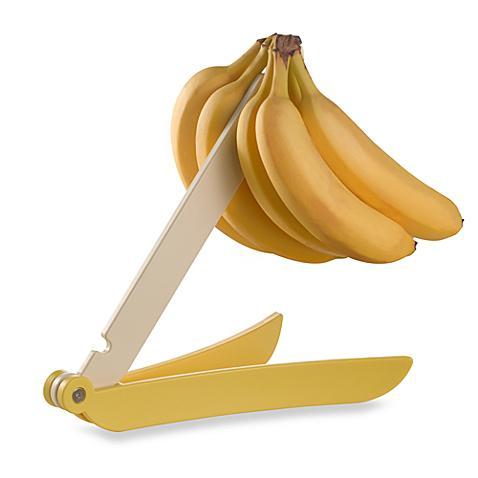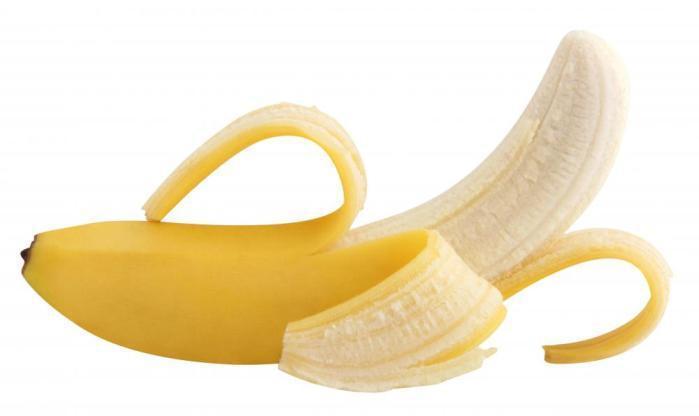The first image is the image on the left, the second image is the image on the right. Evaluate the accuracy of this statement regarding the images: "In one of the images, at least part of a banana has been cut into slices.". Is it true? Answer yes or no. No. The first image is the image on the left, the second image is the image on the right. For the images displayed, is the sentence "The left image contains a banana bunch with stems connected, and the right image includes at least part of an exposed, unpeeled banana." factually correct? Answer yes or no. Yes. 